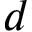<formula> <loc_0><loc_0><loc_500><loc_500>d</formula> 